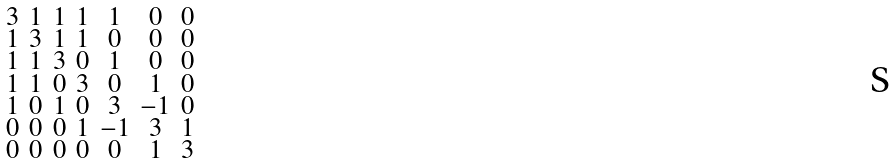<formula> <loc_0><loc_0><loc_500><loc_500>\begin{smallmatrix} 3 & 1 & 1 & 1 & 1 & 0 & 0 \\ 1 & 3 & 1 & 1 & 0 & 0 & 0 \\ 1 & 1 & 3 & 0 & 1 & 0 & 0 \\ 1 & 1 & 0 & 3 & 0 & 1 & 0 \\ 1 & 0 & 1 & 0 & 3 & - 1 & 0 \\ 0 & 0 & 0 & 1 & - 1 & 3 & 1 \\ 0 & 0 & 0 & 0 & 0 & 1 & 3 \end{smallmatrix}</formula> 